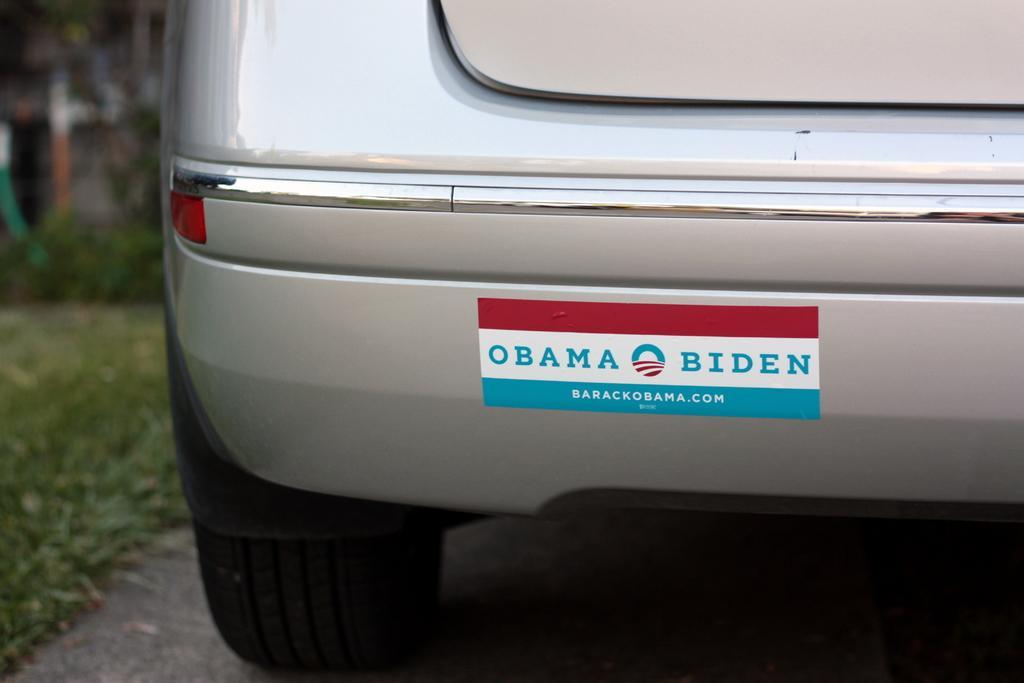In one or two sentences, can you explain what this image depicts? This is the picture of a vehicle. In this image there is a vehicle on the road and there is a sticker on the vehicle. On the left side of the image there is a tree. At the bottom there is grass and road. 